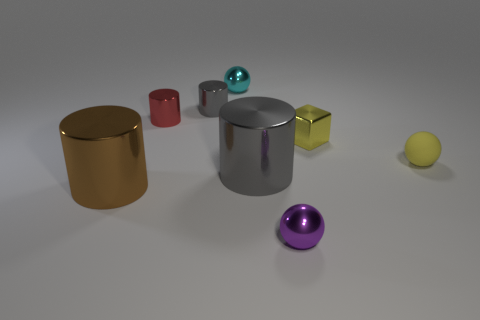How many things are yellow spheres or red cylinders?
Your answer should be very brief. 2. There is a object that is both behind the red cylinder and to the right of the small gray cylinder; what shape is it?
Provide a short and direct response. Sphere. How many big shiny cylinders are there?
Give a very brief answer. 2. The tiny cylinder that is the same material as the tiny gray thing is what color?
Offer a very short reply. Red. Are there more small yellow metallic things than gray objects?
Ensure brevity in your answer.  No. There is a ball that is both behind the large brown cylinder and in front of the red metal thing; what is its size?
Make the answer very short. Small. What is the material of the sphere that is the same color as the cube?
Offer a very short reply. Rubber. Are there an equal number of tiny cyan things in front of the red metal thing and big brown rubber objects?
Your response must be concise. Yes. Do the red object and the yellow block have the same size?
Your response must be concise. Yes. The thing that is both left of the tiny gray metallic cylinder and behind the big gray metal thing is what color?
Your answer should be compact. Red. 